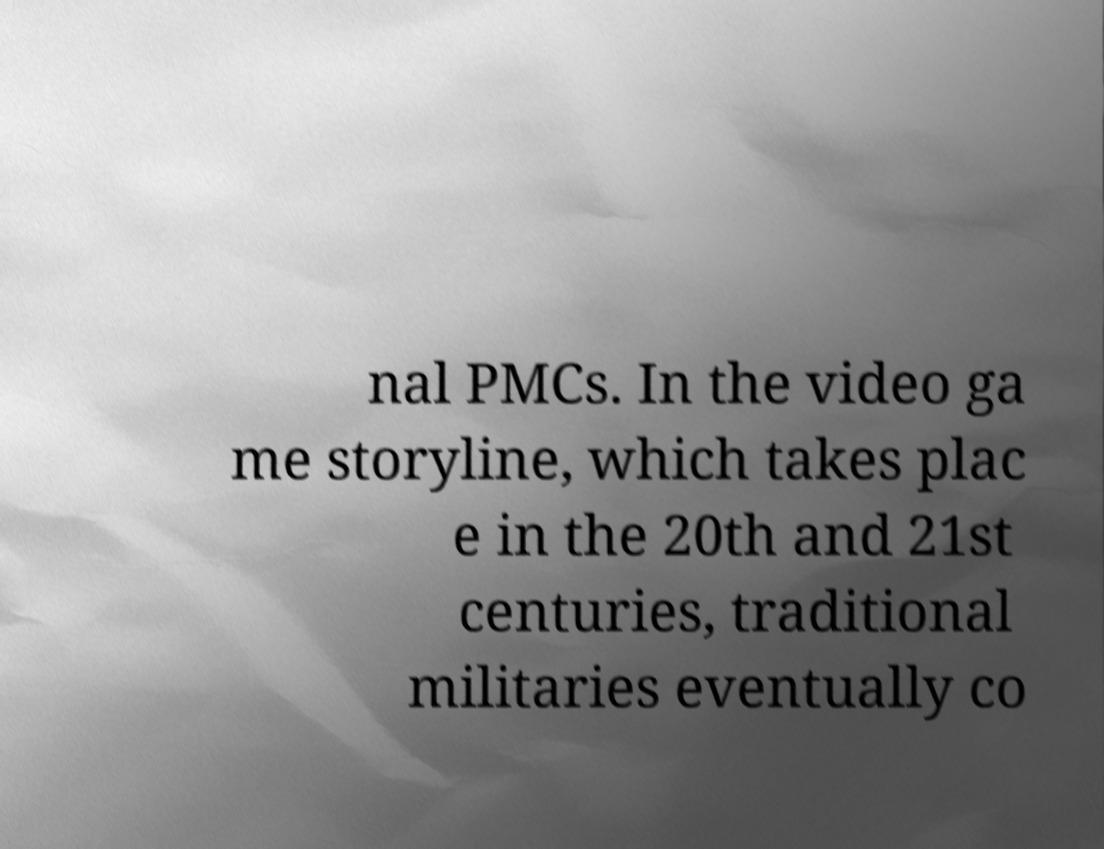For documentation purposes, I need the text within this image transcribed. Could you provide that? nal PMCs. In the video ga me storyline, which takes plac e in the 20th and 21st centuries, traditional militaries eventually co 